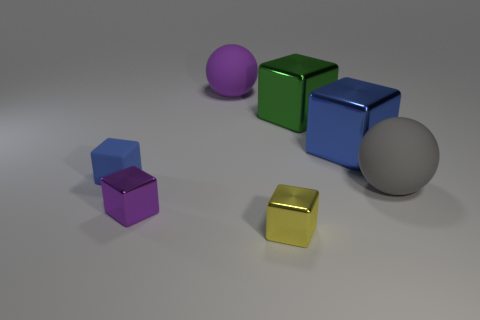What could be the purpose of arranging these objects in this manner? The objects might be arranged for a comparative study of shapes, sizes, and colors, possibly for an educational purpose or a visual demonstration. Each object's distinct features could be used to teach concepts of geometry, color theory, or even composition in a photograph. 